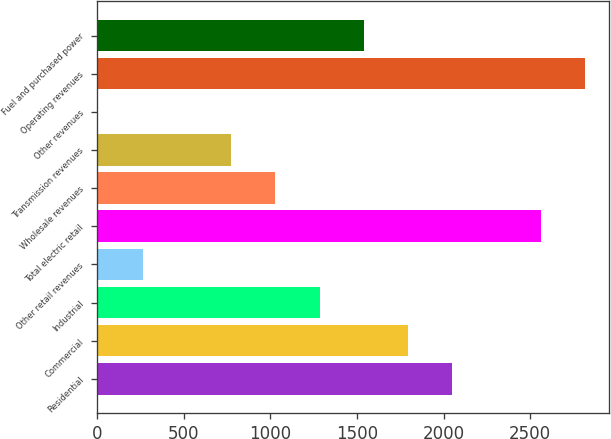<chart> <loc_0><loc_0><loc_500><loc_500><bar_chart><fcel>Residential<fcel>Commercial<fcel>Industrial<fcel>Other retail revenues<fcel>Total electric retail<fcel>Wholesale revenues<fcel>Transmission revenues<fcel>Other revenues<fcel>Operating revenues<fcel>Fuel and purchased power<nl><fcel>2050.78<fcel>1795.12<fcel>1283.8<fcel>261.16<fcel>2562.1<fcel>1028.14<fcel>772.48<fcel>5.5<fcel>2817.76<fcel>1539.46<nl></chart> 